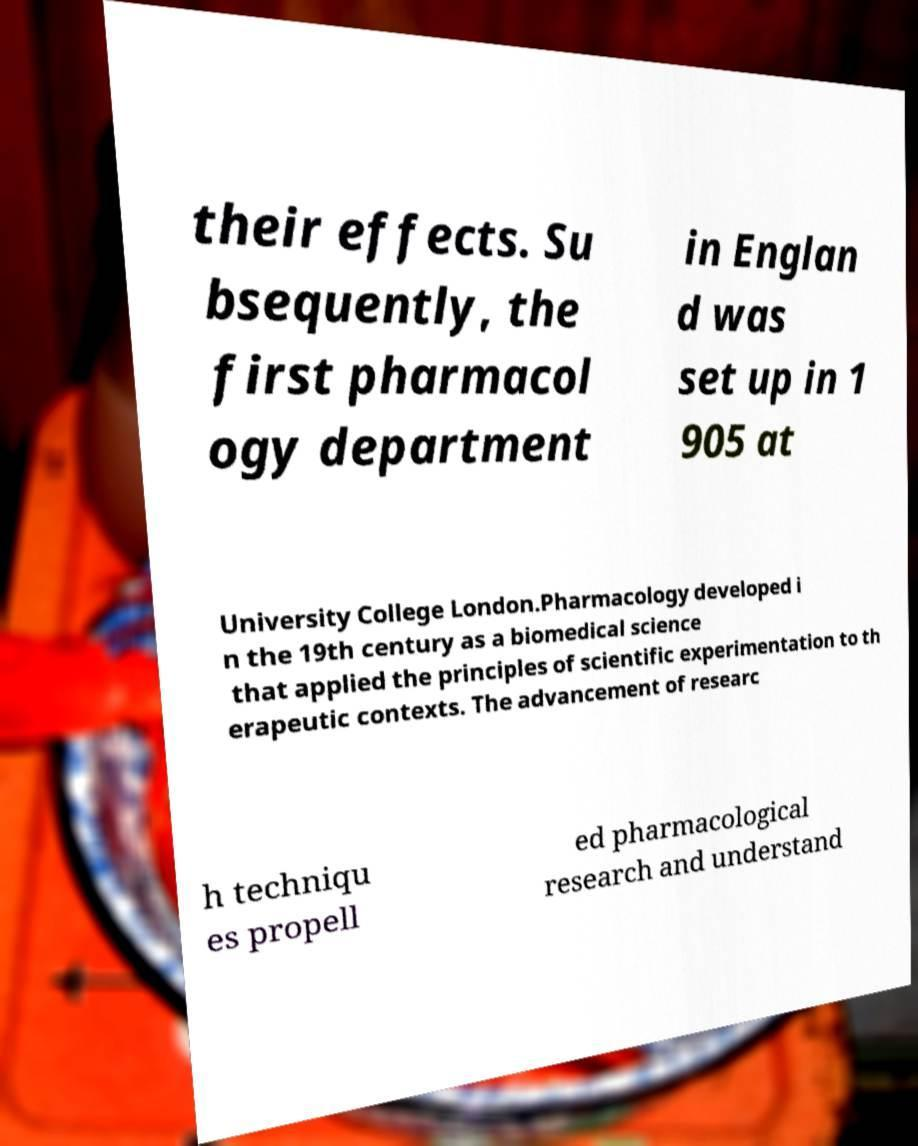Could you extract and type out the text from this image? their effects. Su bsequently, the first pharmacol ogy department in Englan d was set up in 1 905 at University College London.Pharmacology developed i n the 19th century as a biomedical science that applied the principles of scientific experimentation to th erapeutic contexts. The advancement of researc h techniqu es propell ed pharmacological research and understand 